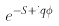Convert formula to latex. <formula><loc_0><loc_0><loc_500><loc_500>e ^ { - S + i q \phi }</formula> 